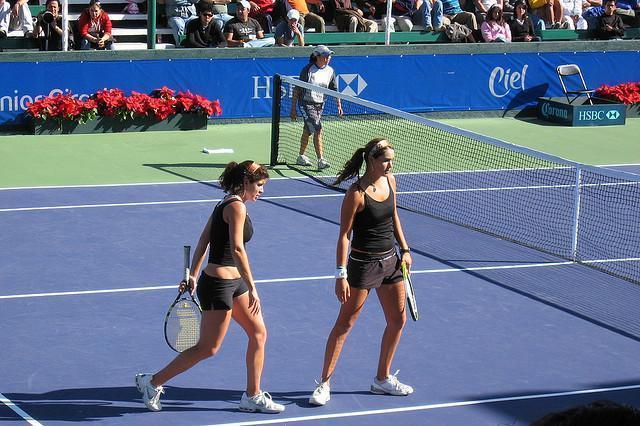How many people are there?
Give a very brief answer. 4. 